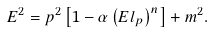<formula> <loc_0><loc_0><loc_500><loc_500>E ^ { 2 } = p ^ { 2 } \left [ 1 - \alpha \left ( E l _ { p } \right ) ^ { n } \right ] + m ^ { 2 } .</formula> 